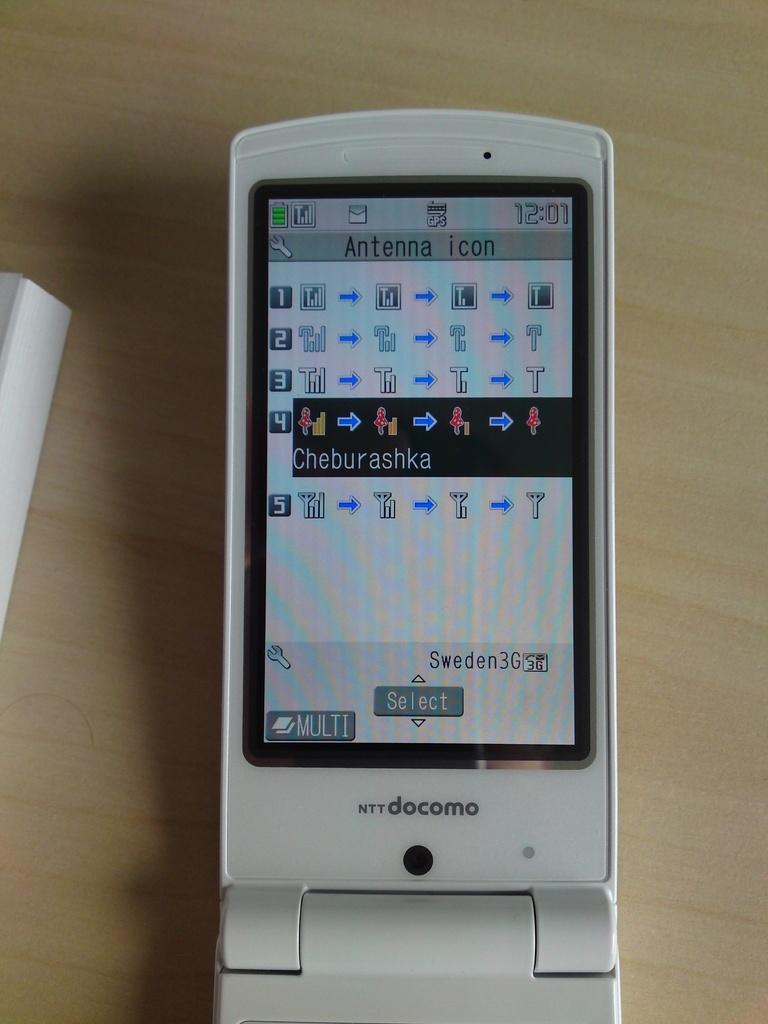<image>
Write a terse but informative summary of the picture. A cellphone is searching for the proper icon and choosing Cheburashka 